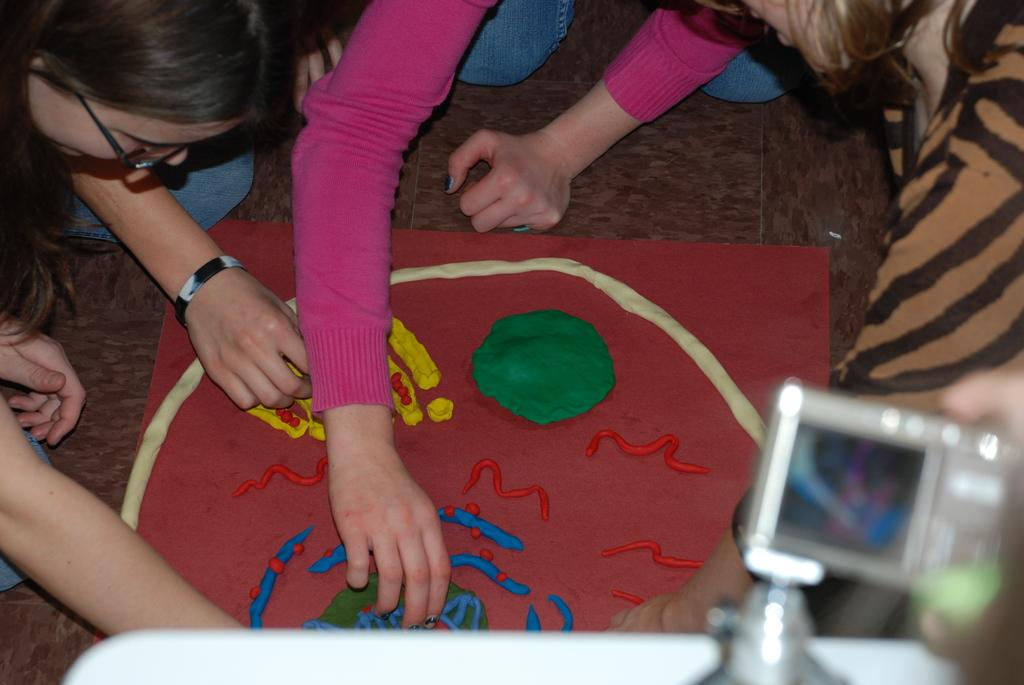Who or what can be seen in the image? There are people in the image. What is the main object in the center of the image? There is an art piece made with clay in the center of the image. What can be seen on the right side of the image? There is a camera on the right side of the image. What type of jelly is being used to create the art piece in the image? There is no jelly present in the image; the art piece is made with clay. Can you tell me how the father is interacting with the art piece in the image? There is no father present in the image, and therefore no interaction with the art piece can be observed. 